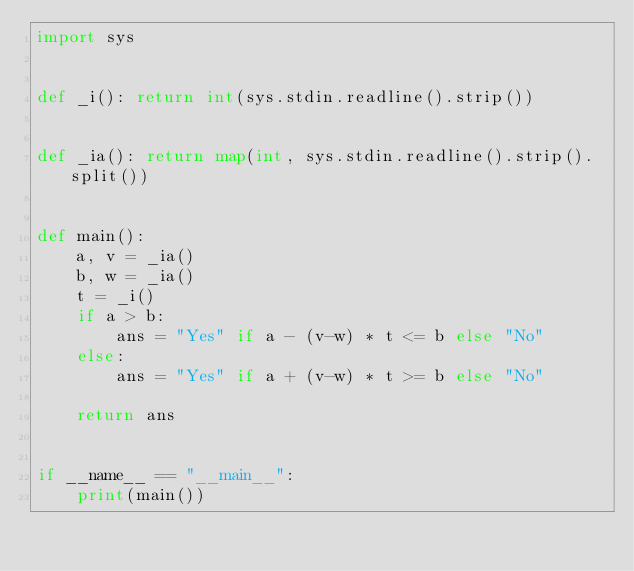<code> <loc_0><loc_0><loc_500><loc_500><_Python_>import sys


def _i(): return int(sys.stdin.readline().strip())


def _ia(): return map(int, sys.stdin.readline().strip().split())


def main():
    a, v = _ia()
    b, w = _ia()
    t = _i()
    if a > b:
        ans = "Yes" if a - (v-w) * t <= b else "No"
    else:
        ans = "Yes" if a + (v-w) * t >= b else "No"

    return ans


if __name__ == "__main__":
    print(main())
</code> 